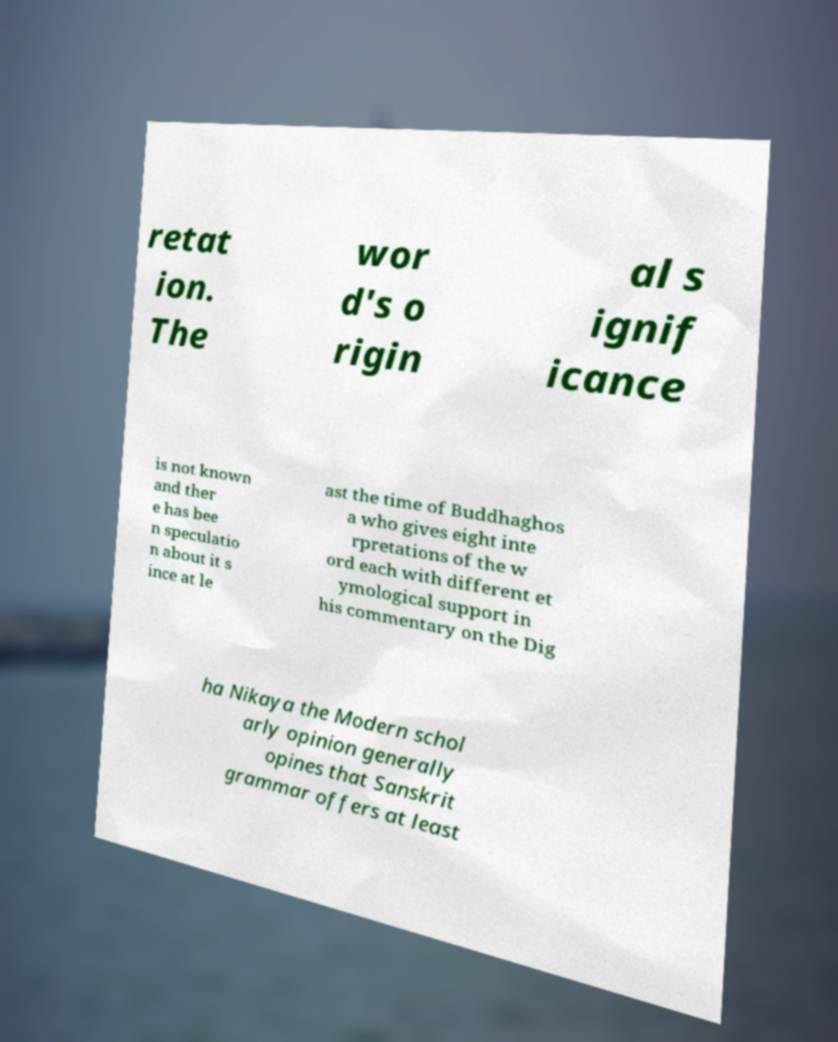I need the written content from this picture converted into text. Can you do that? retat ion. The wor d's o rigin al s ignif icance is not known and ther e has bee n speculatio n about it s ince at le ast the time of Buddhaghos a who gives eight inte rpretations of the w ord each with different et ymological support in his commentary on the Dig ha Nikaya the Modern schol arly opinion generally opines that Sanskrit grammar offers at least 